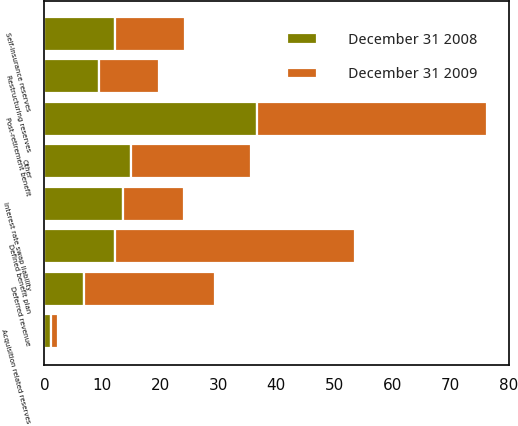Convert chart. <chart><loc_0><loc_0><loc_500><loc_500><stacked_bar_chart><ecel><fcel>Post-retirement benefit<fcel>Defined benefit plan<fcel>Restructuring reserves<fcel>Self-insurance reserves<fcel>Interest rate swap liability<fcel>Acquisition related reserves<fcel>Deferred revenue<fcel>Other<nl><fcel>December 31 2009<fcel>39.7<fcel>41.4<fcel>10.4<fcel>12.1<fcel>10.6<fcel>1.1<fcel>22.5<fcel>20.6<nl><fcel>December 31 2008<fcel>36.7<fcel>12.1<fcel>9.4<fcel>12.1<fcel>13.5<fcel>1.2<fcel>6.9<fcel>15<nl></chart> 